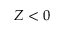Convert formula to latex. <formula><loc_0><loc_0><loc_500><loc_500>Z < 0</formula> 